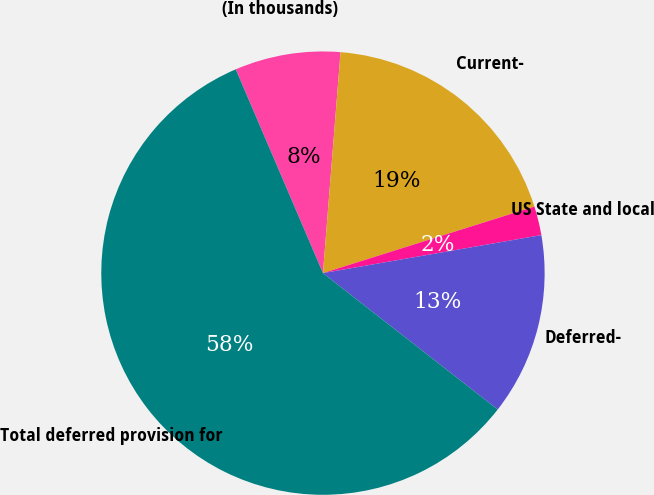<chart> <loc_0><loc_0><loc_500><loc_500><pie_chart><fcel>(In thousands)<fcel>Current-<fcel>US State and local<fcel>Deferred-<fcel>Total deferred provision for<nl><fcel>7.7%<fcel>18.88%<fcel>2.11%<fcel>13.29%<fcel>58.01%<nl></chart> 